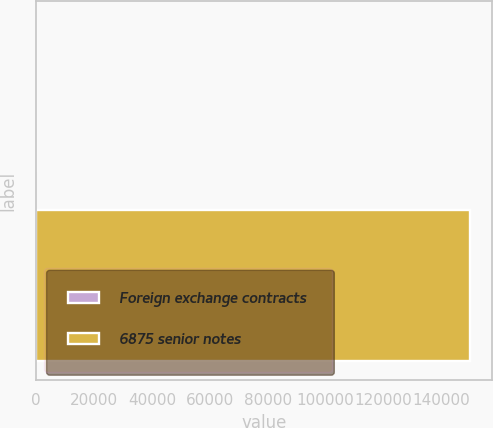<chart> <loc_0><loc_0><loc_500><loc_500><bar_chart><fcel>Foreign exchange contracts<fcel>6875 senior notes<nl><fcel>41<fcel>150000<nl></chart> 